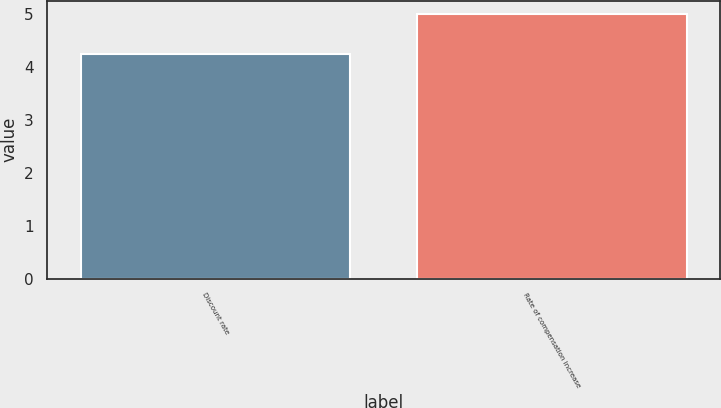Convert chart to OTSL. <chart><loc_0><loc_0><loc_500><loc_500><bar_chart><fcel>Discount rate<fcel>Rate of compensation increase<nl><fcel>4.25<fcel>5<nl></chart> 